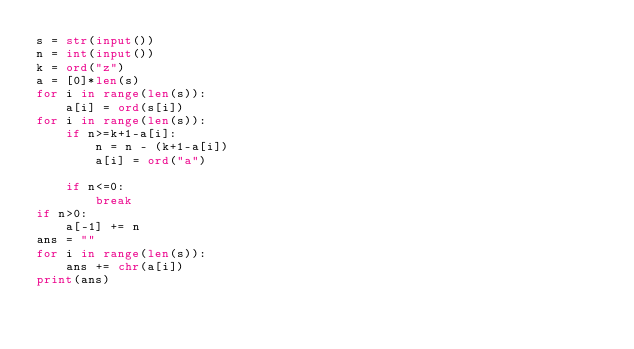Convert code to text. <code><loc_0><loc_0><loc_500><loc_500><_Python_>s = str(input())
n = int(input())
k = ord("z")
a = [0]*len(s)
for i in range(len(s)):
    a[i] = ord(s[i])
for i in range(len(s)):
    if n>=k+1-a[i]:
        n = n - (k+1-a[i])
        a[i] = ord("a")
    
    if n<=0:
        break
if n>0:
    a[-1] += n
ans = ""
for i in range(len(s)):
    ans += chr(a[i])
print(ans)
</code> 